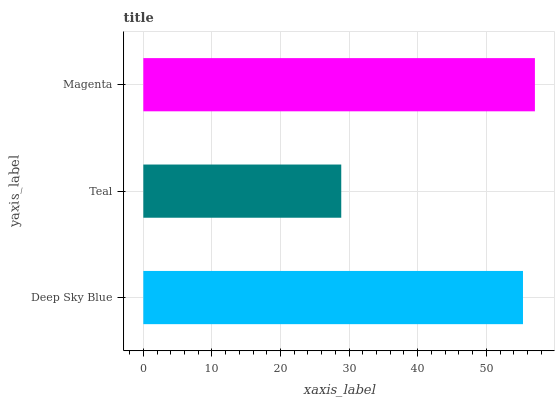Is Teal the minimum?
Answer yes or no. Yes. Is Magenta the maximum?
Answer yes or no. Yes. Is Magenta the minimum?
Answer yes or no. No. Is Teal the maximum?
Answer yes or no. No. Is Magenta greater than Teal?
Answer yes or no. Yes. Is Teal less than Magenta?
Answer yes or no. Yes. Is Teal greater than Magenta?
Answer yes or no. No. Is Magenta less than Teal?
Answer yes or no. No. Is Deep Sky Blue the high median?
Answer yes or no. Yes. Is Deep Sky Blue the low median?
Answer yes or no. Yes. Is Magenta the high median?
Answer yes or no. No. Is Teal the low median?
Answer yes or no. No. 